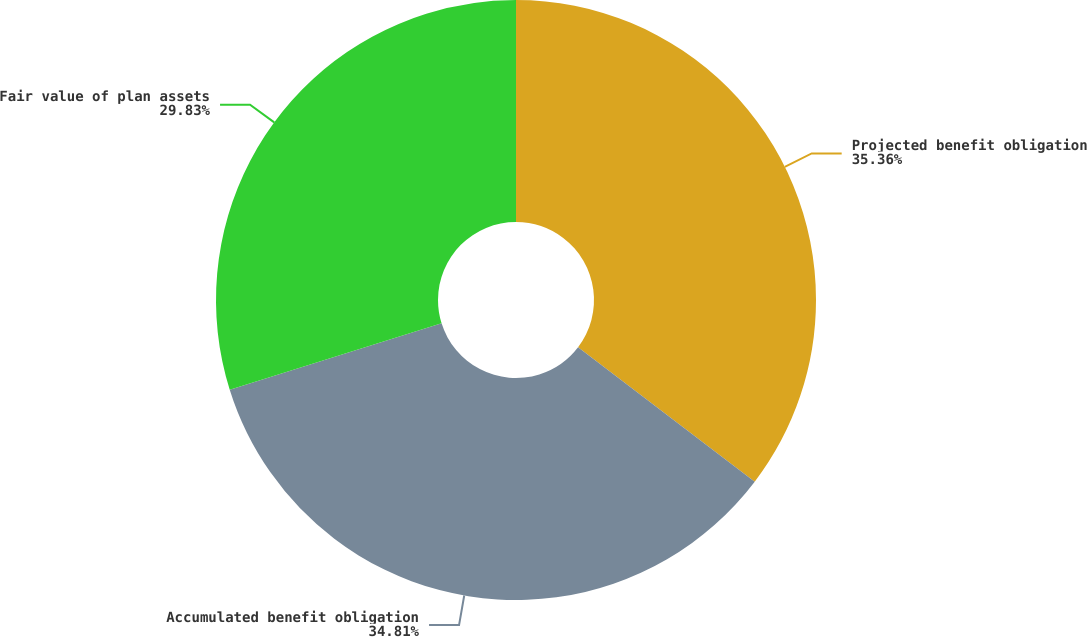Convert chart. <chart><loc_0><loc_0><loc_500><loc_500><pie_chart><fcel>Projected benefit obligation<fcel>Accumulated benefit obligation<fcel>Fair value of plan assets<nl><fcel>35.35%<fcel>34.81%<fcel>29.83%<nl></chart> 